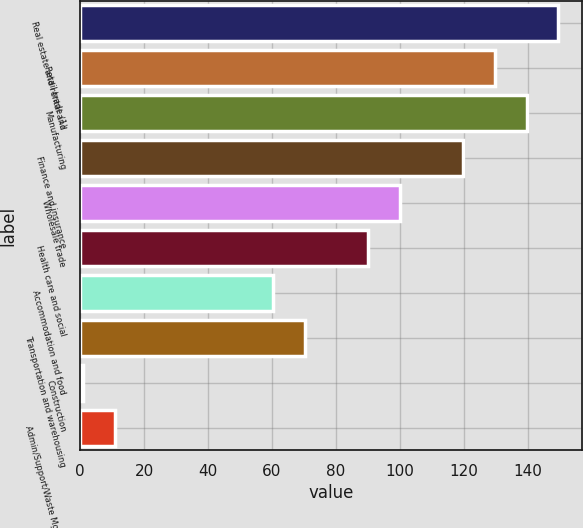<chart> <loc_0><loc_0><loc_500><loc_500><bar_chart><fcel>Real estate and rental and<fcel>Retail trade (1)<fcel>Manufacturing<fcel>Finance and insurance<fcel>Wholesale trade<fcel>Health care and social<fcel>Accommodation and food<fcel>Transportation and warehousing<fcel>Construction<fcel>Admin/Support/Waste Mgmt and<nl><fcel>149.5<fcel>129.7<fcel>139.6<fcel>119.8<fcel>100<fcel>90.1<fcel>60.4<fcel>70.3<fcel>1<fcel>10.9<nl></chart> 